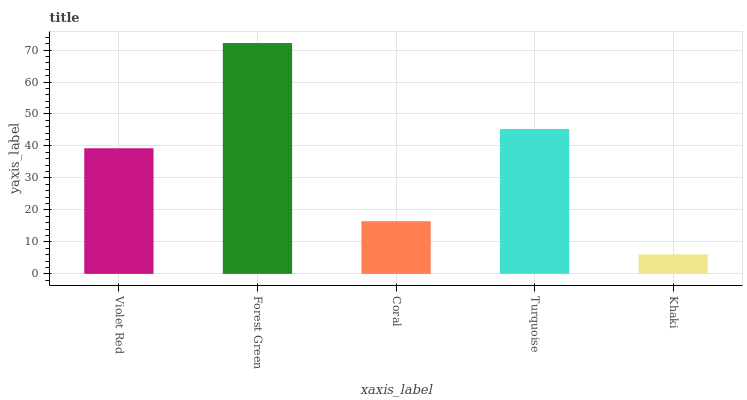Is Khaki the minimum?
Answer yes or no. Yes. Is Forest Green the maximum?
Answer yes or no. Yes. Is Coral the minimum?
Answer yes or no. No. Is Coral the maximum?
Answer yes or no. No. Is Forest Green greater than Coral?
Answer yes or no. Yes. Is Coral less than Forest Green?
Answer yes or no. Yes. Is Coral greater than Forest Green?
Answer yes or no. No. Is Forest Green less than Coral?
Answer yes or no. No. Is Violet Red the high median?
Answer yes or no. Yes. Is Violet Red the low median?
Answer yes or no. Yes. Is Turquoise the high median?
Answer yes or no. No. Is Khaki the low median?
Answer yes or no. No. 